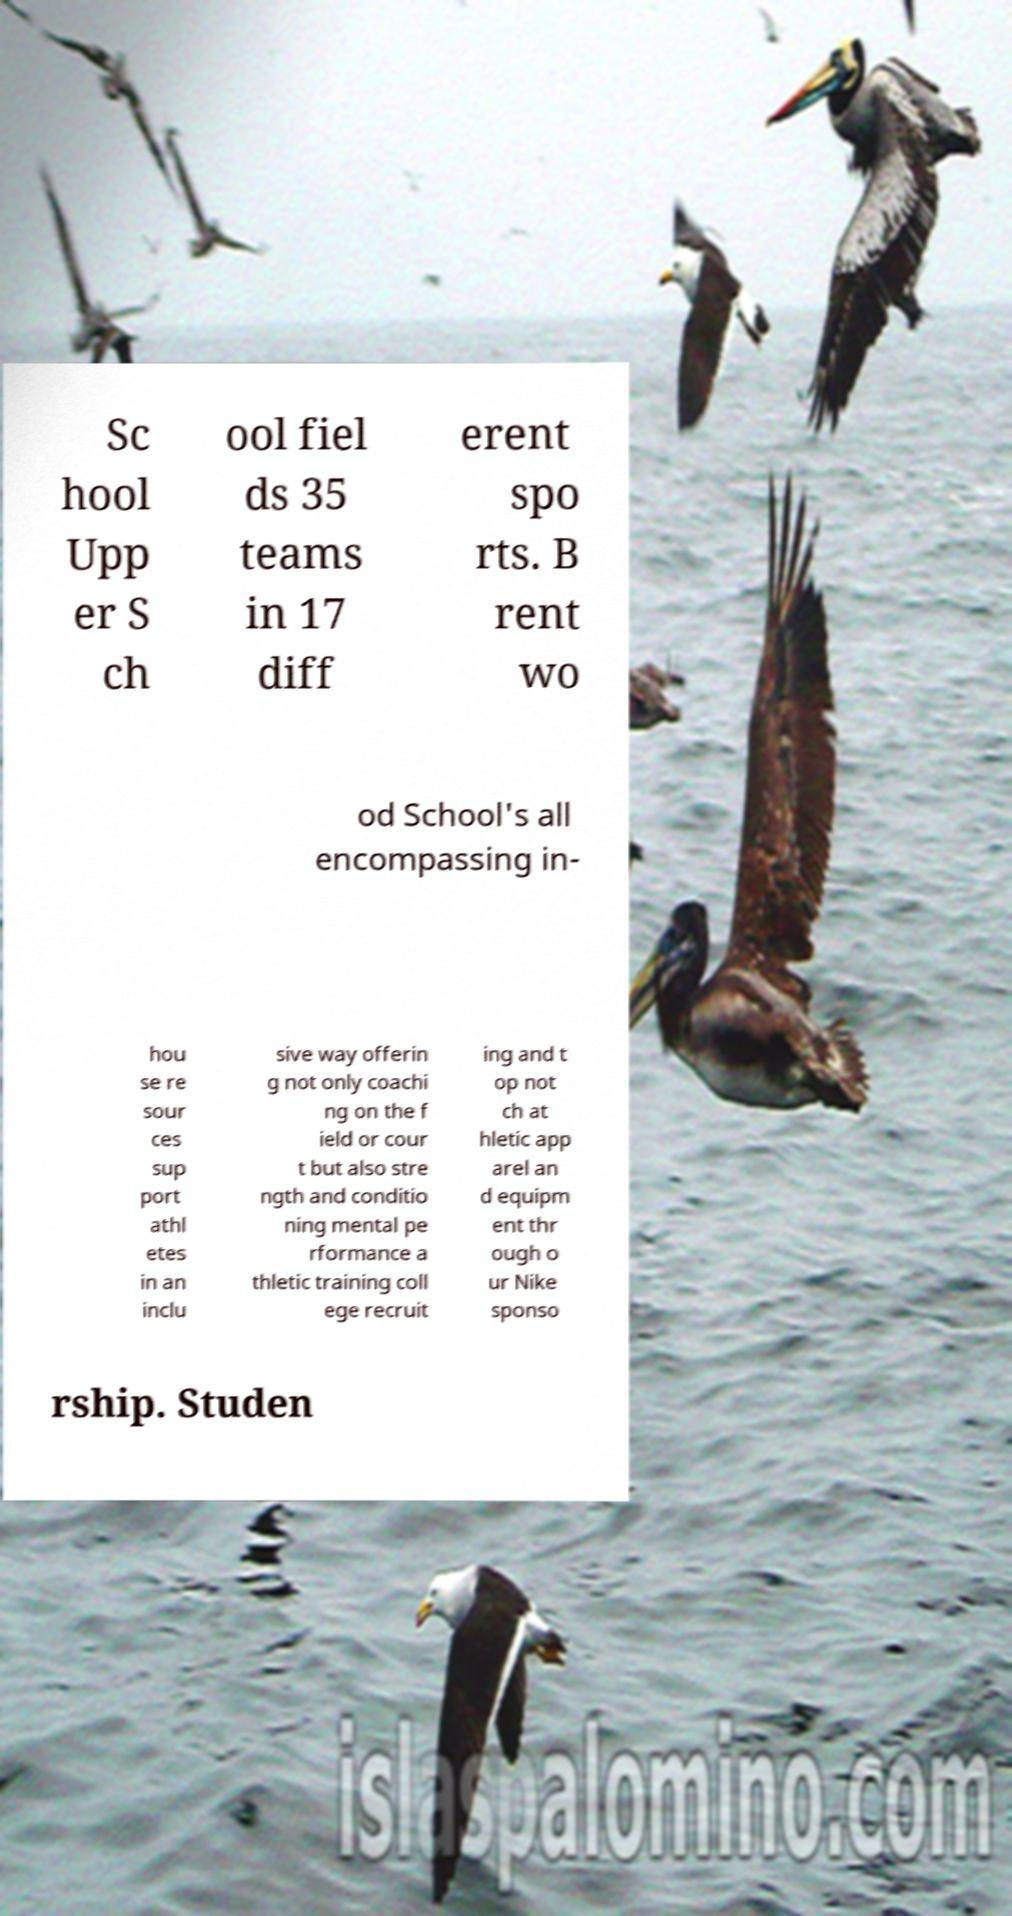Could you extract and type out the text from this image? Sc hool Upp er S ch ool fiel ds 35 teams in 17 diff erent spo rts. B rent wo od School's all encompassing in- hou se re sour ces sup port athl etes in an inclu sive way offerin g not only coachi ng on the f ield or cour t but also stre ngth and conditio ning mental pe rformance a thletic training coll ege recruit ing and t op not ch at hletic app arel an d equipm ent thr ough o ur Nike sponso rship. Studen 